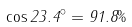Convert formula to latex. <formula><loc_0><loc_0><loc_500><loc_500>\cos 2 3 . 4 ^ { \circ } = 9 1 . 8 \%</formula> 